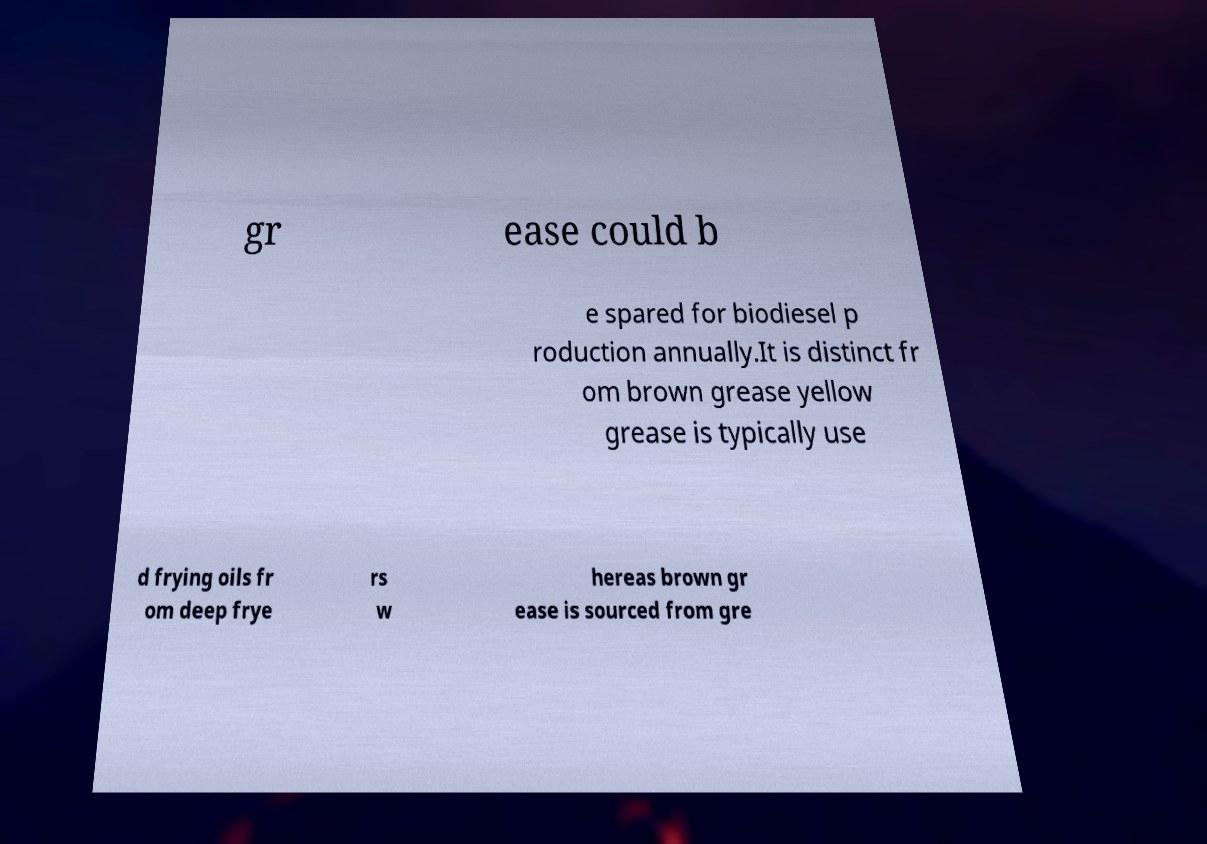Could you assist in decoding the text presented in this image and type it out clearly? gr ease could b e spared for biodiesel p roduction annually.It is distinct fr om brown grease yellow grease is typically use d frying oils fr om deep frye rs w hereas brown gr ease is sourced from gre 